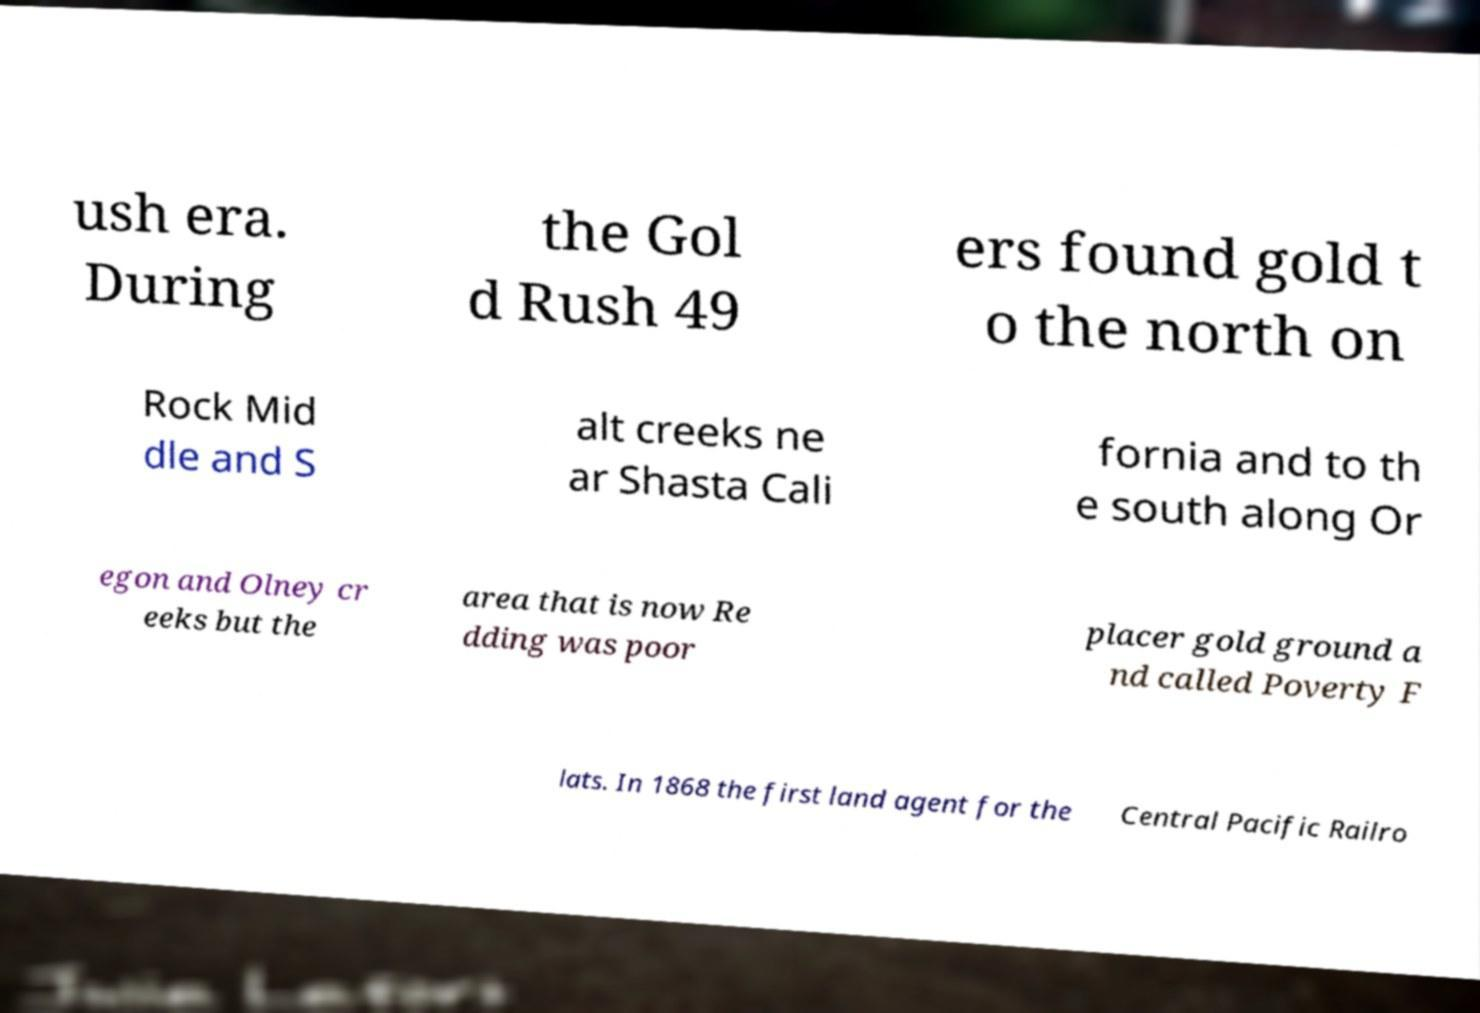Please read and relay the text visible in this image. What does it say? ush era. During the Gol d Rush 49 ers found gold t o the north on Rock Mid dle and S alt creeks ne ar Shasta Cali fornia and to th e south along Or egon and Olney cr eeks but the area that is now Re dding was poor placer gold ground a nd called Poverty F lats. In 1868 the first land agent for the Central Pacific Railro 